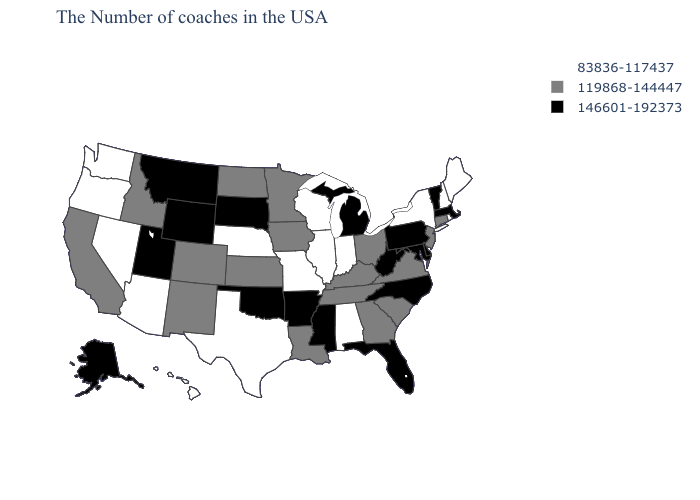Among the states that border Maryland , does West Virginia have the highest value?
Keep it brief. Yes. Does Hawaii have a higher value than Vermont?
Give a very brief answer. No. What is the highest value in the West ?
Give a very brief answer. 146601-192373. Does the map have missing data?
Quick response, please. No. What is the value of Iowa?
Quick response, please. 119868-144447. Among the states that border New York , which have the highest value?
Give a very brief answer. Massachusetts, Vermont, Pennsylvania. What is the value of Tennessee?
Be succinct. 119868-144447. What is the value of North Carolina?
Concise answer only. 146601-192373. What is the lowest value in the USA?
Short answer required. 83836-117437. Among the states that border Vermont , which have the highest value?
Short answer required. Massachusetts. Does Ohio have a higher value than Florida?
Short answer required. No. Name the states that have a value in the range 119868-144447?
Concise answer only. Connecticut, New Jersey, Virginia, South Carolina, Ohio, Georgia, Kentucky, Tennessee, Louisiana, Minnesota, Iowa, Kansas, North Dakota, Colorado, New Mexico, Idaho, California. What is the value of Rhode Island?
Keep it brief. 83836-117437. 